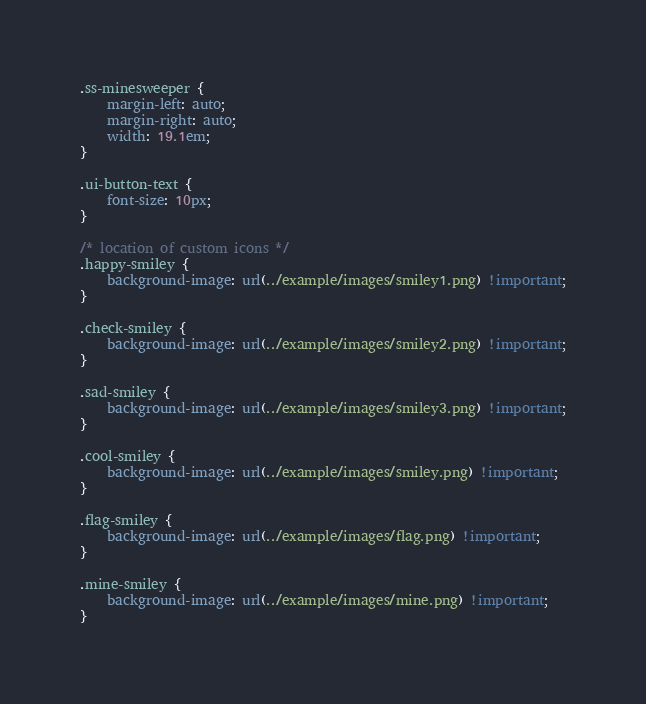<code> <loc_0><loc_0><loc_500><loc_500><_CSS_>
.ss-minesweeper {
    margin-left: auto;
    margin-right: auto;
    width: 19.1em;
}

.ui-button-text {
    font-size: 10px;
}

/* location of custom icons */
.happy-smiley {
    background-image: url(../example/images/smiley1.png) !important;
}

.check-smiley {
    background-image: url(../example/images/smiley2.png) !important;
}

.sad-smiley {
    background-image: url(../example/images/smiley3.png) !important;
}

.cool-smiley {
    background-image: url(../example/images/smiley.png) !important;
}

.flag-smiley {
    background-image: url(../example/images/flag.png) !important;
}

.mine-smiley {
    background-image: url(../example/images/mine.png) !important;
}

</code> 